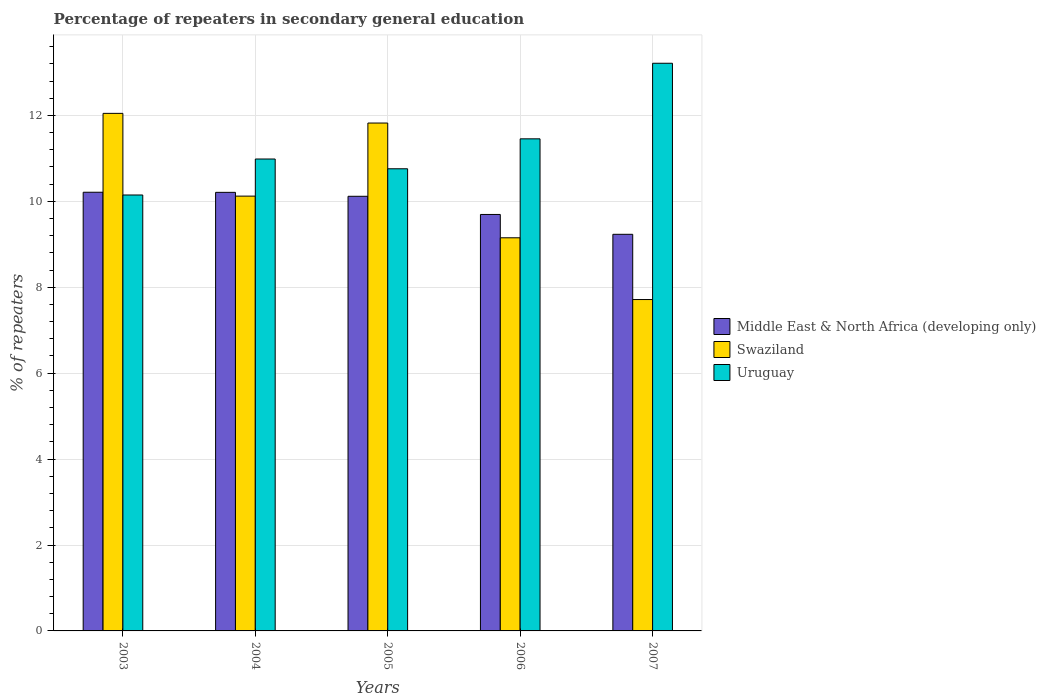How many different coloured bars are there?
Make the answer very short. 3. Are the number of bars per tick equal to the number of legend labels?
Make the answer very short. Yes. How many bars are there on the 4th tick from the left?
Your answer should be very brief. 3. What is the percentage of repeaters in secondary general education in Swaziland in 2005?
Offer a very short reply. 11.82. Across all years, what is the maximum percentage of repeaters in secondary general education in Uruguay?
Make the answer very short. 13.21. Across all years, what is the minimum percentage of repeaters in secondary general education in Middle East & North Africa (developing only)?
Ensure brevity in your answer.  9.23. What is the total percentage of repeaters in secondary general education in Swaziland in the graph?
Provide a short and direct response. 50.86. What is the difference between the percentage of repeaters in secondary general education in Middle East & North Africa (developing only) in 2004 and that in 2006?
Offer a very short reply. 0.51. What is the difference between the percentage of repeaters in secondary general education in Uruguay in 2003 and the percentage of repeaters in secondary general education in Swaziland in 2006?
Offer a very short reply. 1. What is the average percentage of repeaters in secondary general education in Swaziland per year?
Keep it short and to the point. 10.17. In the year 2004, what is the difference between the percentage of repeaters in secondary general education in Middle East & North Africa (developing only) and percentage of repeaters in secondary general education in Swaziland?
Give a very brief answer. 0.09. In how many years, is the percentage of repeaters in secondary general education in Uruguay greater than 13.2 %?
Offer a very short reply. 1. What is the ratio of the percentage of repeaters in secondary general education in Swaziland in 2005 to that in 2006?
Provide a succinct answer. 1.29. What is the difference between the highest and the second highest percentage of repeaters in secondary general education in Middle East & North Africa (developing only)?
Offer a very short reply. 0. What is the difference between the highest and the lowest percentage of repeaters in secondary general education in Swaziland?
Ensure brevity in your answer.  4.33. In how many years, is the percentage of repeaters in secondary general education in Swaziland greater than the average percentage of repeaters in secondary general education in Swaziland taken over all years?
Provide a succinct answer. 2. Is the sum of the percentage of repeaters in secondary general education in Swaziland in 2003 and 2004 greater than the maximum percentage of repeaters in secondary general education in Middle East & North Africa (developing only) across all years?
Make the answer very short. Yes. What does the 3rd bar from the left in 2004 represents?
Your response must be concise. Uruguay. What does the 1st bar from the right in 2007 represents?
Ensure brevity in your answer.  Uruguay. Is it the case that in every year, the sum of the percentage of repeaters in secondary general education in Swaziland and percentage of repeaters in secondary general education in Middle East & North Africa (developing only) is greater than the percentage of repeaters in secondary general education in Uruguay?
Offer a terse response. Yes. How many bars are there?
Provide a succinct answer. 15. Are all the bars in the graph horizontal?
Offer a very short reply. No. How many years are there in the graph?
Provide a succinct answer. 5. Where does the legend appear in the graph?
Provide a short and direct response. Center right. How many legend labels are there?
Offer a terse response. 3. How are the legend labels stacked?
Provide a succinct answer. Vertical. What is the title of the graph?
Provide a short and direct response. Percentage of repeaters in secondary general education. What is the label or title of the Y-axis?
Ensure brevity in your answer.  % of repeaters. What is the % of repeaters of Middle East & North Africa (developing only) in 2003?
Keep it short and to the point. 10.21. What is the % of repeaters in Swaziland in 2003?
Keep it short and to the point. 12.05. What is the % of repeaters of Uruguay in 2003?
Your response must be concise. 10.15. What is the % of repeaters in Middle East & North Africa (developing only) in 2004?
Provide a succinct answer. 10.21. What is the % of repeaters of Swaziland in 2004?
Make the answer very short. 10.12. What is the % of repeaters in Uruguay in 2004?
Your answer should be compact. 10.99. What is the % of repeaters of Middle East & North Africa (developing only) in 2005?
Keep it short and to the point. 10.12. What is the % of repeaters of Swaziland in 2005?
Your answer should be very brief. 11.82. What is the % of repeaters in Uruguay in 2005?
Offer a terse response. 10.76. What is the % of repeaters in Middle East & North Africa (developing only) in 2006?
Provide a short and direct response. 9.69. What is the % of repeaters of Swaziland in 2006?
Provide a short and direct response. 9.15. What is the % of repeaters in Uruguay in 2006?
Offer a terse response. 11.46. What is the % of repeaters in Middle East & North Africa (developing only) in 2007?
Your response must be concise. 9.23. What is the % of repeaters in Swaziland in 2007?
Offer a very short reply. 7.71. What is the % of repeaters of Uruguay in 2007?
Offer a very short reply. 13.21. Across all years, what is the maximum % of repeaters of Middle East & North Africa (developing only)?
Offer a very short reply. 10.21. Across all years, what is the maximum % of repeaters in Swaziland?
Give a very brief answer. 12.05. Across all years, what is the maximum % of repeaters of Uruguay?
Ensure brevity in your answer.  13.21. Across all years, what is the minimum % of repeaters of Middle East & North Africa (developing only)?
Provide a succinct answer. 9.23. Across all years, what is the minimum % of repeaters of Swaziland?
Give a very brief answer. 7.71. Across all years, what is the minimum % of repeaters of Uruguay?
Keep it short and to the point. 10.15. What is the total % of repeaters of Middle East & North Africa (developing only) in the graph?
Make the answer very short. 49.47. What is the total % of repeaters of Swaziland in the graph?
Offer a terse response. 50.86. What is the total % of repeaters in Uruguay in the graph?
Provide a succinct answer. 56.56. What is the difference between the % of repeaters in Middle East & North Africa (developing only) in 2003 and that in 2004?
Offer a very short reply. 0. What is the difference between the % of repeaters in Swaziland in 2003 and that in 2004?
Offer a very short reply. 1.93. What is the difference between the % of repeaters of Uruguay in 2003 and that in 2004?
Your answer should be very brief. -0.84. What is the difference between the % of repeaters in Middle East & North Africa (developing only) in 2003 and that in 2005?
Offer a very short reply. 0.09. What is the difference between the % of repeaters of Swaziland in 2003 and that in 2005?
Make the answer very short. 0.23. What is the difference between the % of repeaters of Uruguay in 2003 and that in 2005?
Your response must be concise. -0.61. What is the difference between the % of repeaters in Middle East & North Africa (developing only) in 2003 and that in 2006?
Ensure brevity in your answer.  0.52. What is the difference between the % of repeaters of Swaziland in 2003 and that in 2006?
Ensure brevity in your answer.  2.9. What is the difference between the % of repeaters in Uruguay in 2003 and that in 2006?
Your response must be concise. -1.31. What is the difference between the % of repeaters in Swaziland in 2003 and that in 2007?
Give a very brief answer. 4.33. What is the difference between the % of repeaters in Uruguay in 2003 and that in 2007?
Give a very brief answer. -3.07. What is the difference between the % of repeaters in Middle East & North Africa (developing only) in 2004 and that in 2005?
Offer a terse response. 0.09. What is the difference between the % of repeaters of Swaziland in 2004 and that in 2005?
Give a very brief answer. -1.7. What is the difference between the % of repeaters of Uruguay in 2004 and that in 2005?
Keep it short and to the point. 0.23. What is the difference between the % of repeaters of Middle East & North Africa (developing only) in 2004 and that in 2006?
Offer a very short reply. 0.51. What is the difference between the % of repeaters in Swaziland in 2004 and that in 2006?
Give a very brief answer. 0.97. What is the difference between the % of repeaters of Uruguay in 2004 and that in 2006?
Your answer should be very brief. -0.47. What is the difference between the % of repeaters of Middle East & North Africa (developing only) in 2004 and that in 2007?
Keep it short and to the point. 0.98. What is the difference between the % of repeaters in Swaziland in 2004 and that in 2007?
Give a very brief answer. 2.41. What is the difference between the % of repeaters of Uruguay in 2004 and that in 2007?
Make the answer very short. -2.23. What is the difference between the % of repeaters of Middle East & North Africa (developing only) in 2005 and that in 2006?
Give a very brief answer. 0.42. What is the difference between the % of repeaters of Swaziland in 2005 and that in 2006?
Your answer should be very brief. 2.67. What is the difference between the % of repeaters of Uruguay in 2005 and that in 2006?
Your answer should be compact. -0.7. What is the difference between the % of repeaters of Middle East & North Africa (developing only) in 2005 and that in 2007?
Provide a succinct answer. 0.89. What is the difference between the % of repeaters of Swaziland in 2005 and that in 2007?
Offer a terse response. 4.11. What is the difference between the % of repeaters of Uruguay in 2005 and that in 2007?
Keep it short and to the point. -2.46. What is the difference between the % of repeaters in Middle East & North Africa (developing only) in 2006 and that in 2007?
Provide a short and direct response. 0.46. What is the difference between the % of repeaters in Swaziland in 2006 and that in 2007?
Give a very brief answer. 1.44. What is the difference between the % of repeaters of Uruguay in 2006 and that in 2007?
Ensure brevity in your answer.  -1.76. What is the difference between the % of repeaters in Middle East & North Africa (developing only) in 2003 and the % of repeaters in Swaziland in 2004?
Keep it short and to the point. 0.09. What is the difference between the % of repeaters in Middle East & North Africa (developing only) in 2003 and the % of repeaters in Uruguay in 2004?
Your answer should be compact. -0.77. What is the difference between the % of repeaters in Swaziland in 2003 and the % of repeaters in Uruguay in 2004?
Offer a very short reply. 1.06. What is the difference between the % of repeaters of Middle East & North Africa (developing only) in 2003 and the % of repeaters of Swaziland in 2005?
Give a very brief answer. -1.61. What is the difference between the % of repeaters in Middle East & North Africa (developing only) in 2003 and the % of repeaters in Uruguay in 2005?
Your response must be concise. -0.55. What is the difference between the % of repeaters in Swaziland in 2003 and the % of repeaters in Uruguay in 2005?
Provide a short and direct response. 1.29. What is the difference between the % of repeaters of Middle East & North Africa (developing only) in 2003 and the % of repeaters of Swaziland in 2006?
Make the answer very short. 1.06. What is the difference between the % of repeaters in Middle East & North Africa (developing only) in 2003 and the % of repeaters in Uruguay in 2006?
Offer a terse response. -1.24. What is the difference between the % of repeaters in Swaziland in 2003 and the % of repeaters in Uruguay in 2006?
Your answer should be compact. 0.59. What is the difference between the % of repeaters of Middle East & North Africa (developing only) in 2003 and the % of repeaters of Swaziland in 2007?
Offer a very short reply. 2.5. What is the difference between the % of repeaters in Middle East & North Africa (developing only) in 2003 and the % of repeaters in Uruguay in 2007?
Make the answer very short. -3. What is the difference between the % of repeaters of Swaziland in 2003 and the % of repeaters of Uruguay in 2007?
Your response must be concise. -1.17. What is the difference between the % of repeaters in Middle East & North Africa (developing only) in 2004 and the % of repeaters in Swaziland in 2005?
Ensure brevity in your answer.  -1.61. What is the difference between the % of repeaters of Middle East & North Africa (developing only) in 2004 and the % of repeaters of Uruguay in 2005?
Keep it short and to the point. -0.55. What is the difference between the % of repeaters of Swaziland in 2004 and the % of repeaters of Uruguay in 2005?
Provide a short and direct response. -0.64. What is the difference between the % of repeaters of Middle East & North Africa (developing only) in 2004 and the % of repeaters of Swaziland in 2006?
Keep it short and to the point. 1.06. What is the difference between the % of repeaters of Middle East & North Africa (developing only) in 2004 and the % of repeaters of Uruguay in 2006?
Your answer should be very brief. -1.25. What is the difference between the % of repeaters in Swaziland in 2004 and the % of repeaters in Uruguay in 2006?
Offer a very short reply. -1.33. What is the difference between the % of repeaters in Middle East & North Africa (developing only) in 2004 and the % of repeaters in Swaziland in 2007?
Provide a succinct answer. 2.5. What is the difference between the % of repeaters of Middle East & North Africa (developing only) in 2004 and the % of repeaters of Uruguay in 2007?
Keep it short and to the point. -3.01. What is the difference between the % of repeaters of Swaziland in 2004 and the % of repeaters of Uruguay in 2007?
Your response must be concise. -3.09. What is the difference between the % of repeaters in Middle East & North Africa (developing only) in 2005 and the % of repeaters in Swaziland in 2006?
Keep it short and to the point. 0.97. What is the difference between the % of repeaters in Middle East & North Africa (developing only) in 2005 and the % of repeaters in Uruguay in 2006?
Your answer should be very brief. -1.34. What is the difference between the % of repeaters in Swaziland in 2005 and the % of repeaters in Uruguay in 2006?
Give a very brief answer. 0.37. What is the difference between the % of repeaters of Middle East & North Africa (developing only) in 2005 and the % of repeaters of Swaziland in 2007?
Your answer should be very brief. 2.4. What is the difference between the % of repeaters in Middle East & North Africa (developing only) in 2005 and the % of repeaters in Uruguay in 2007?
Offer a very short reply. -3.1. What is the difference between the % of repeaters in Swaziland in 2005 and the % of repeaters in Uruguay in 2007?
Provide a succinct answer. -1.39. What is the difference between the % of repeaters of Middle East & North Africa (developing only) in 2006 and the % of repeaters of Swaziland in 2007?
Make the answer very short. 1.98. What is the difference between the % of repeaters in Middle East & North Africa (developing only) in 2006 and the % of repeaters in Uruguay in 2007?
Provide a succinct answer. -3.52. What is the difference between the % of repeaters of Swaziland in 2006 and the % of repeaters of Uruguay in 2007?
Your response must be concise. -4.06. What is the average % of repeaters in Middle East & North Africa (developing only) per year?
Keep it short and to the point. 9.89. What is the average % of repeaters in Swaziland per year?
Provide a succinct answer. 10.17. What is the average % of repeaters of Uruguay per year?
Provide a succinct answer. 11.31. In the year 2003, what is the difference between the % of repeaters of Middle East & North Africa (developing only) and % of repeaters of Swaziland?
Give a very brief answer. -1.84. In the year 2003, what is the difference between the % of repeaters in Middle East & North Africa (developing only) and % of repeaters in Uruguay?
Make the answer very short. 0.06. In the year 2003, what is the difference between the % of repeaters of Swaziland and % of repeaters of Uruguay?
Provide a short and direct response. 1.9. In the year 2004, what is the difference between the % of repeaters in Middle East & North Africa (developing only) and % of repeaters in Swaziland?
Provide a succinct answer. 0.09. In the year 2004, what is the difference between the % of repeaters of Middle East & North Africa (developing only) and % of repeaters of Uruguay?
Provide a short and direct response. -0.78. In the year 2004, what is the difference between the % of repeaters of Swaziland and % of repeaters of Uruguay?
Your answer should be compact. -0.86. In the year 2005, what is the difference between the % of repeaters of Middle East & North Africa (developing only) and % of repeaters of Swaziland?
Give a very brief answer. -1.7. In the year 2005, what is the difference between the % of repeaters of Middle East & North Africa (developing only) and % of repeaters of Uruguay?
Your answer should be very brief. -0.64. In the year 2005, what is the difference between the % of repeaters of Swaziland and % of repeaters of Uruguay?
Offer a very short reply. 1.06. In the year 2006, what is the difference between the % of repeaters of Middle East & North Africa (developing only) and % of repeaters of Swaziland?
Your response must be concise. 0.54. In the year 2006, what is the difference between the % of repeaters of Middle East & North Africa (developing only) and % of repeaters of Uruguay?
Provide a succinct answer. -1.76. In the year 2006, what is the difference between the % of repeaters of Swaziland and % of repeaters of Uruguay?
Make the answer very short. -2.3. In the year 2007, what is the difference between the % of repeaters of Middle East & North Africa (developing only) and % of repeaters of Swaziland?
Give a very brief answer. 1.52. In the year 2007, what is the difference between the % of repeaters of Middle East & North Africa (developing only) and % of repeaters of Uruguay?
Offer a terse response. -3.98. In the year 2007, what is the difference between the % of repeaters in Swaziland and % of repeaters in Uruguay?
Your response must be concise. -5.5. What is the ratio of the % of repeaters of Swaziland in 2003 to that in 2004?
Your answer should be compact. 1.19. What is the ratio of the % of repeaters in Uruguay in 2003 to that in 2004?
Keep it short and to the point. 0.92. What is the ratio of the % of repeaters of Middle East & North Africa (developing only) in 2003 to that in 2005?
Provide a succinct answer. 1.01. What is the ratio of the % of repeaters in Swaziland in 2003 to that in 2005?
Your answer should be very brief. 1.02. What is the ratio of the % of repeaters of Uruguay in 2003 to that in 2005?
Give a very brief answer. 0.94. What is the ratio of the % of repeaters of Middle East & North Africa (developing only) in 2003 to that in 2006?
Provide a succinct answer. 1.05. What is the ratio of the % of repeaters in Swaziland in 2003 to that in 2006?
Offer a very short reply. 1.32. What is the ratio of the % of repeaters in Uruguay in 2003 to that in 2006?
Ensure brevity in your answer.  0.89. What is the ratio of the % of repeaters of Middle East & North Africa (developing only) in 2003 to that in 2007?
Offer a very short reply. 1.11. What is the ratio of the % of repeaters in Swaziland in 2003 to that in 2007?
Make the answer very short. 1.56. What is the ratio of the % of repeaters in Uruguay in 2003 to that in 2007?
Offer a terse response. 0.77. What is the ratio of the % of repeaters of Middle East & North Africa (developing only) in 2004 to that in 2005?
Make the answer very short. 1.01. What is the ratio of the % of repeaters in Swaziland in 2004 to that in 2005?
Give a very brief answer. 0.86. What is the ratio of the % of repeaters of Uruguay in 2004 to that in 2005?
Ensure brevity in your answer.  1.02. What is the ratio of the % of repeaters in Middle East & North Africa (developing only) in 2004 to that in 2006?
Provide a succinct answer. 1.05. What is the ratio of the % of repeaters of Swaziland in 2004 to that in 2006?
Your answer should be very brief. 1.11. What is the ratio of the % of repeaters of Middle East & North Africa (developing only) in 2004 to that in 2007?
Keep it short and to the point. 1.11. What is the ratio of the % of repeaters in Swaziland in 2004 to that in 2007?
Make the answer very short. 1.31. What is the ratio of the % of repeaters in Uruguay in 2004 to that in 2007?
Keep it short and to the point. 0.83. What is the ratio of the % of repeaters in Middle East & North Africa (developing only) in 2005 to that in 2006?
Provide a short and direct response. 1.04. What is the ratio of the % of repeaters in Swaziland in 2005 to that in 2006?
Provide a short and direct response. 1.29. What is the ratio of the % of repeaters in Uruguay in 2005 to that in 2006?
Provide a succinct answer. 0.94. What is the ratio of the % of repeaters in Middle East & North Africa (developing only) in 2005 to that in 2007?
Give a very brief answer. 1.1. What is the ratio of the % of repeaters in Swaziland in 2005 to that in 2007?
Your answer should be very brief. 1.53. What is the ratio of the % of repeaters in Uruguay in 2005 to that in 2007?
Offer a very short reply. 0.81. What is the ratio of the % of repeaters of Middle East & North Africa (developing only) in 2006 to that in 2007?
Keep it short and to the point. 1.05. What is the ratio of the % of repeaters in Swaziland in 2006 to that in 2007?
Your answer should be compact. 1.19. What is the ratio of the % of repeaters in Uruguay in 2006 to that in 2007?
Provide a short and direct response. 0.87. What is the difference between the highest and the second highest % of repeaters in Middle East & North Africa (developing only)?
Ensure brevity in your answer.  0. What is the difference between the highest and the second highest % of repeaters of Swaziland?
Give a very brief answer. 0.23. What is the difference between the highest and the second highest % of repeaters of Uruguay?
Offer a very short reply. 1.76. What is the difference between the highest and the lowest % of repeaters in Swaziland?
Give a very brief answer. 4.33. What is the difference between the highest and the lowest % of repeaters of Uruguay?
Your response must be concise. 3.07. 